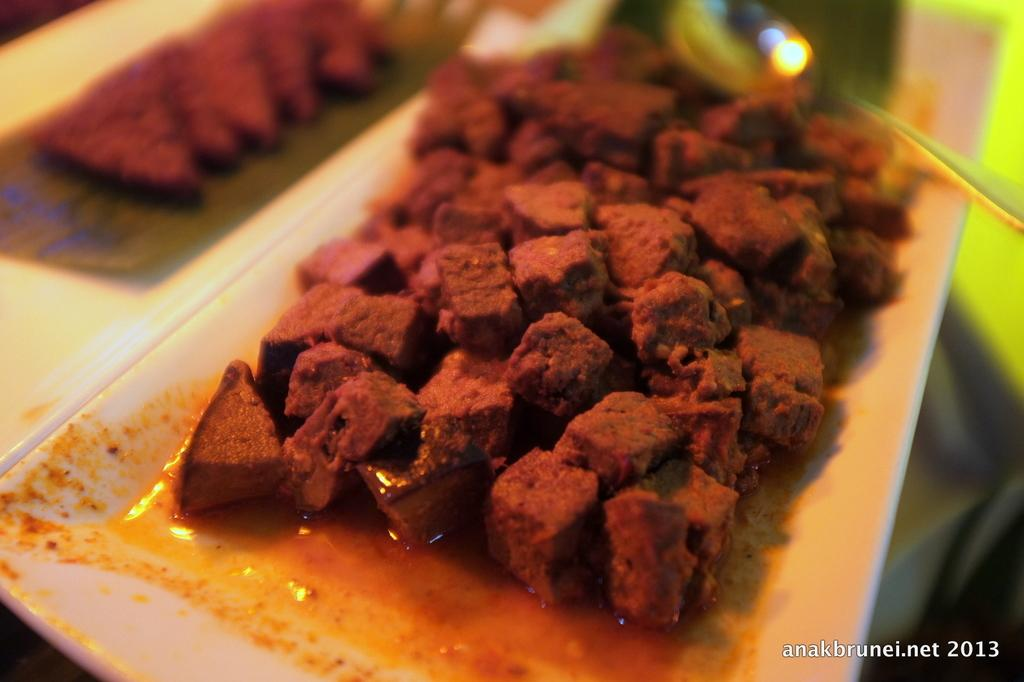How many plates are visible in the image? There are two plates in the image. What is on each of the plates? There is a food item on each plate. Can you describe the utensil that is present in the image? There is a spoon on a food item. What type of earth can be seen in the image? There is no earth present in the image; it features plates with food items and a spoon. How does the spoon affect the person's throat in the image? There is no person or throat present in the image, so it is not possible to determine how the spoon might affect a throat. 